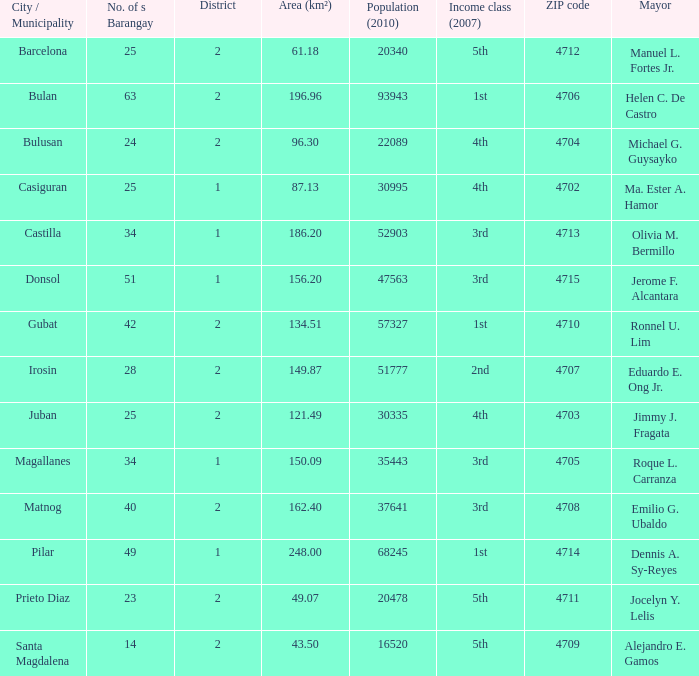51? 1.0. Give me the full table as a dictionary. {'header': ['City / Municipality', 'No. of s Barangay', 'District', 'Area (km²)', 'Population (2010)', 'Income class (2007)', 'ZIP code', 'Mayor'], 'rows': [['Barcelona', '25', '2', '61.18', '20340', '5th', '4712', 'Manuel L. Fortes Jr.'], ['Bulan', '63', '2', '196.96', '93943', '1st', '4706', 'Helen C. De Castro'], ['Bulusan', '24', '2', '96.30', '22089', '4th', '4704', 'Michael G. Guysayko'], ['Casiguran', '25', '1', '87.13', '30995', '4th', '4702', 'Ma. Ester A. Hamor'], ['Castilla', '34', '1', '186.20', '52903', '3rd', '4713', 'Olivia M. Bermillo'], ['Donsol', '51', '1', '156.20', '47563', '3rd', '4715', 'Jerome F. Alcantara'], ['Gubat', '42', '2', '134.51', '57327', '1st', '4710', 'Ronnel U. Lim'], ['Irosin', '28', '2', '149.87', '51777', '2nd', '4707', 'Eduardo E. Ong Jr.'], ['Juban', '25', '2', '121.49', '30335', '4th', '4703', 'Jimmy J. Fragata'], ['Magallanes', '34', '1', '150.09', '35443', '3rd', '4705', 'Roque L. Carranza'], ['Matnog', '40', '2', '162.40', '37641', '3rd', '4708', 'Emilio G. Ubaldo'], ['Pilar', '49', '1', '248.00', '68245', '1st', '4714', 'Dennis A. Sy-Reyes'], ['Prieto Diaz', '23', '2', '49.07', '20478', '5th', '4711', 'Jocelyn Y. Lelis'], ['Santa Magdalena', '14', '2', '43.50', '16520', '5th', '4709', 'Alejandro E. Gamos']]} 